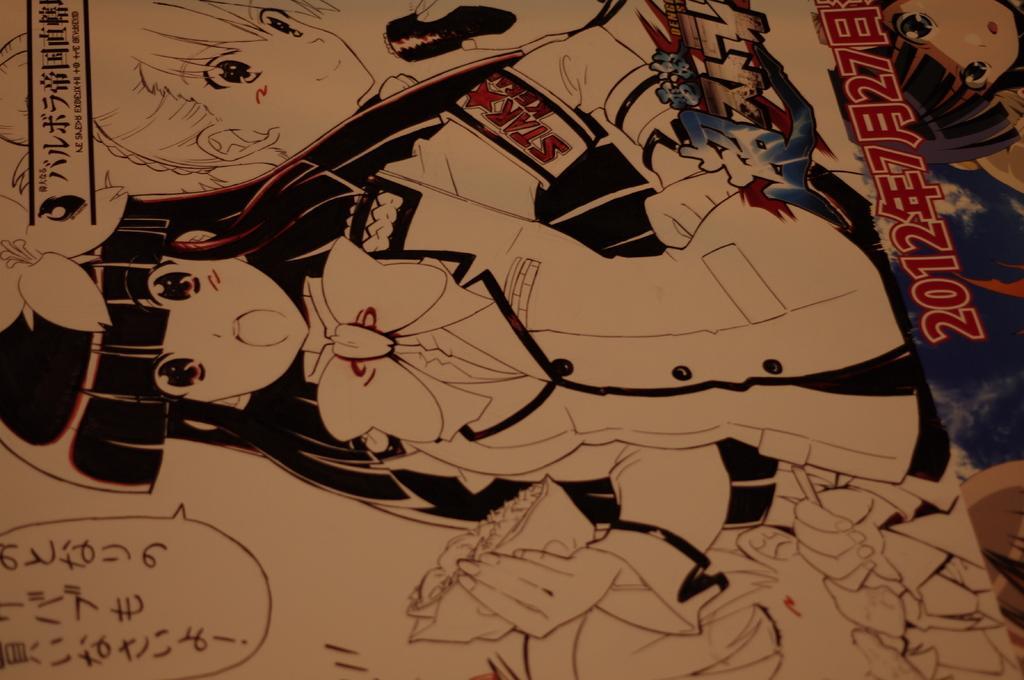Please provide a concise description of this image. This image consists of a cartoon poster. In which there is a girl. At the bottom, there is a text. 